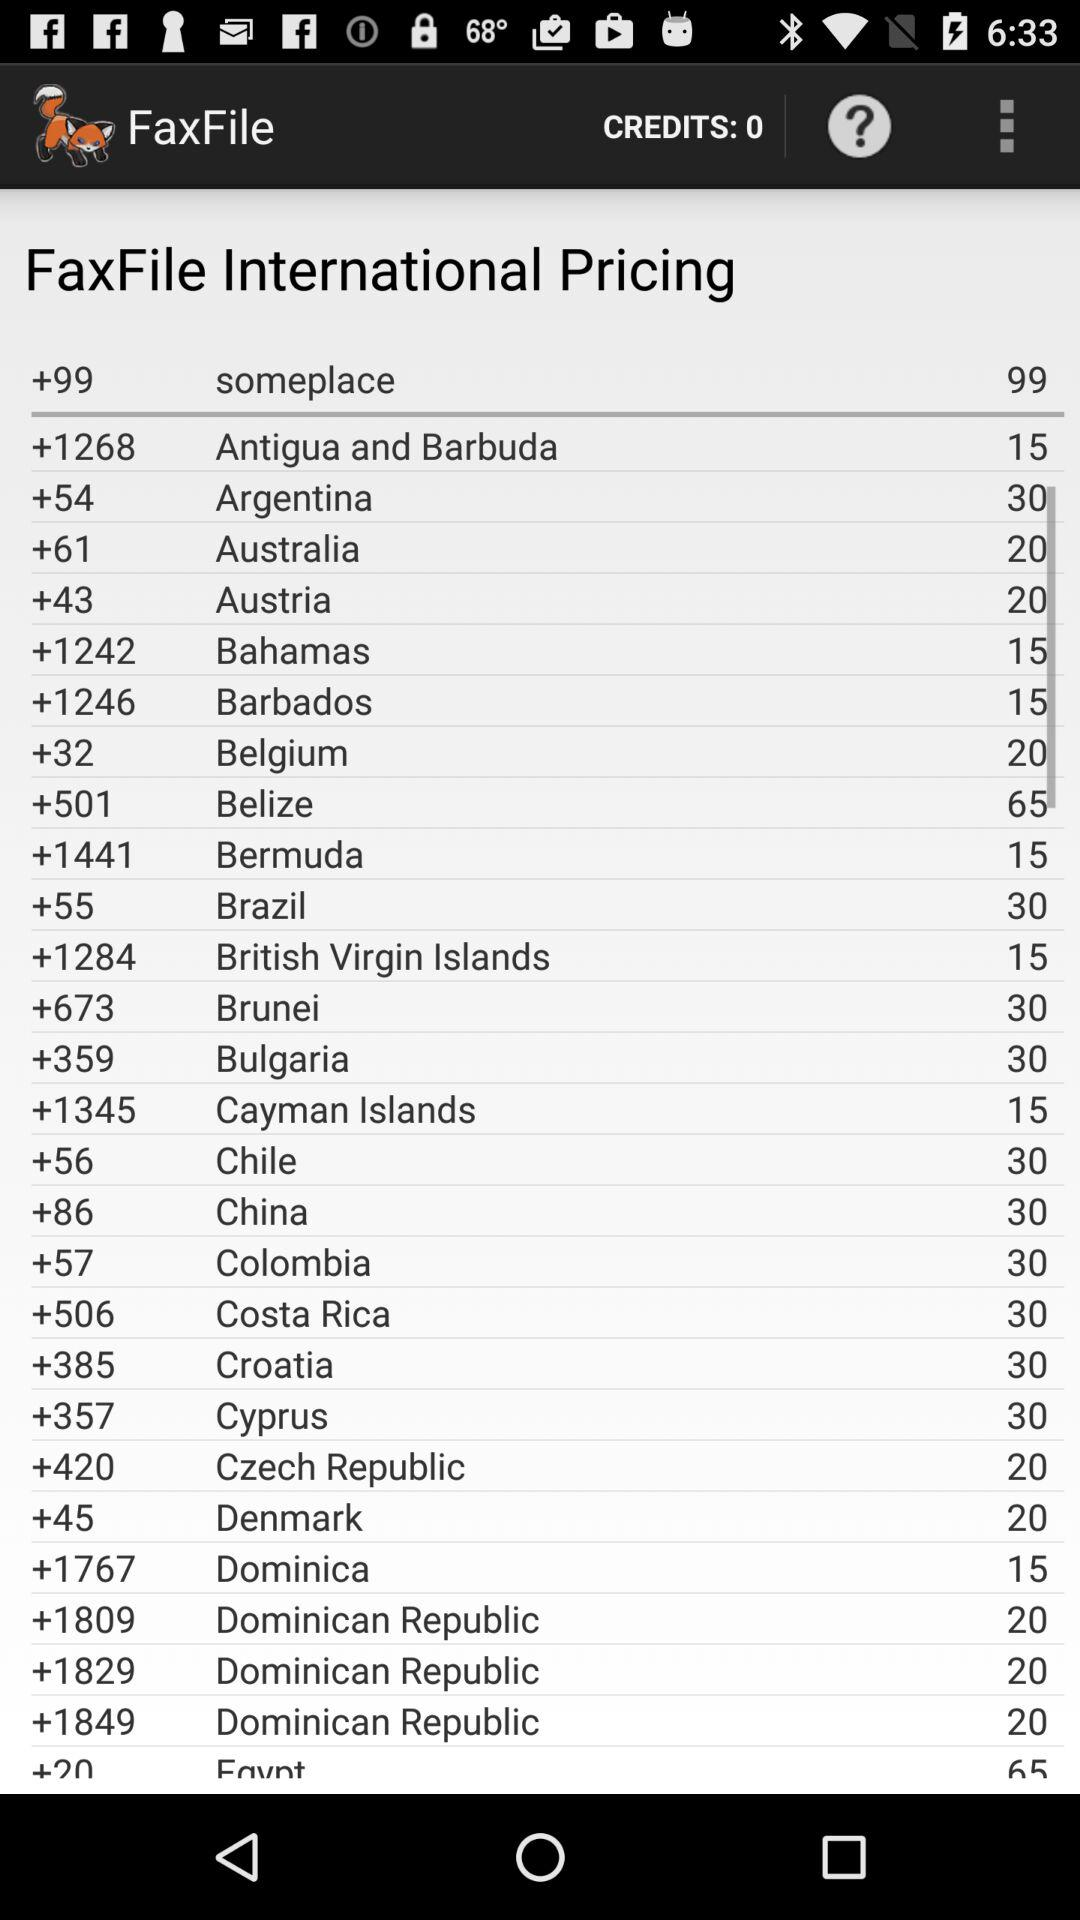Which country's dial code is +55? +55 is the dial code for Brazil. 